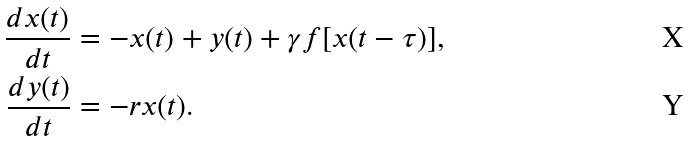Convert formula to latex. <formula><loc_0><loc_0><loc_500><loc_500>\frac { d x ( t ) } { d t } & = - x ( t ) + y ( t ) + \gamma f [ x ( t - \tau ) ] , \\ \frac { d y ( t ) } { d t } & = - r x ( t ) .</formula> 